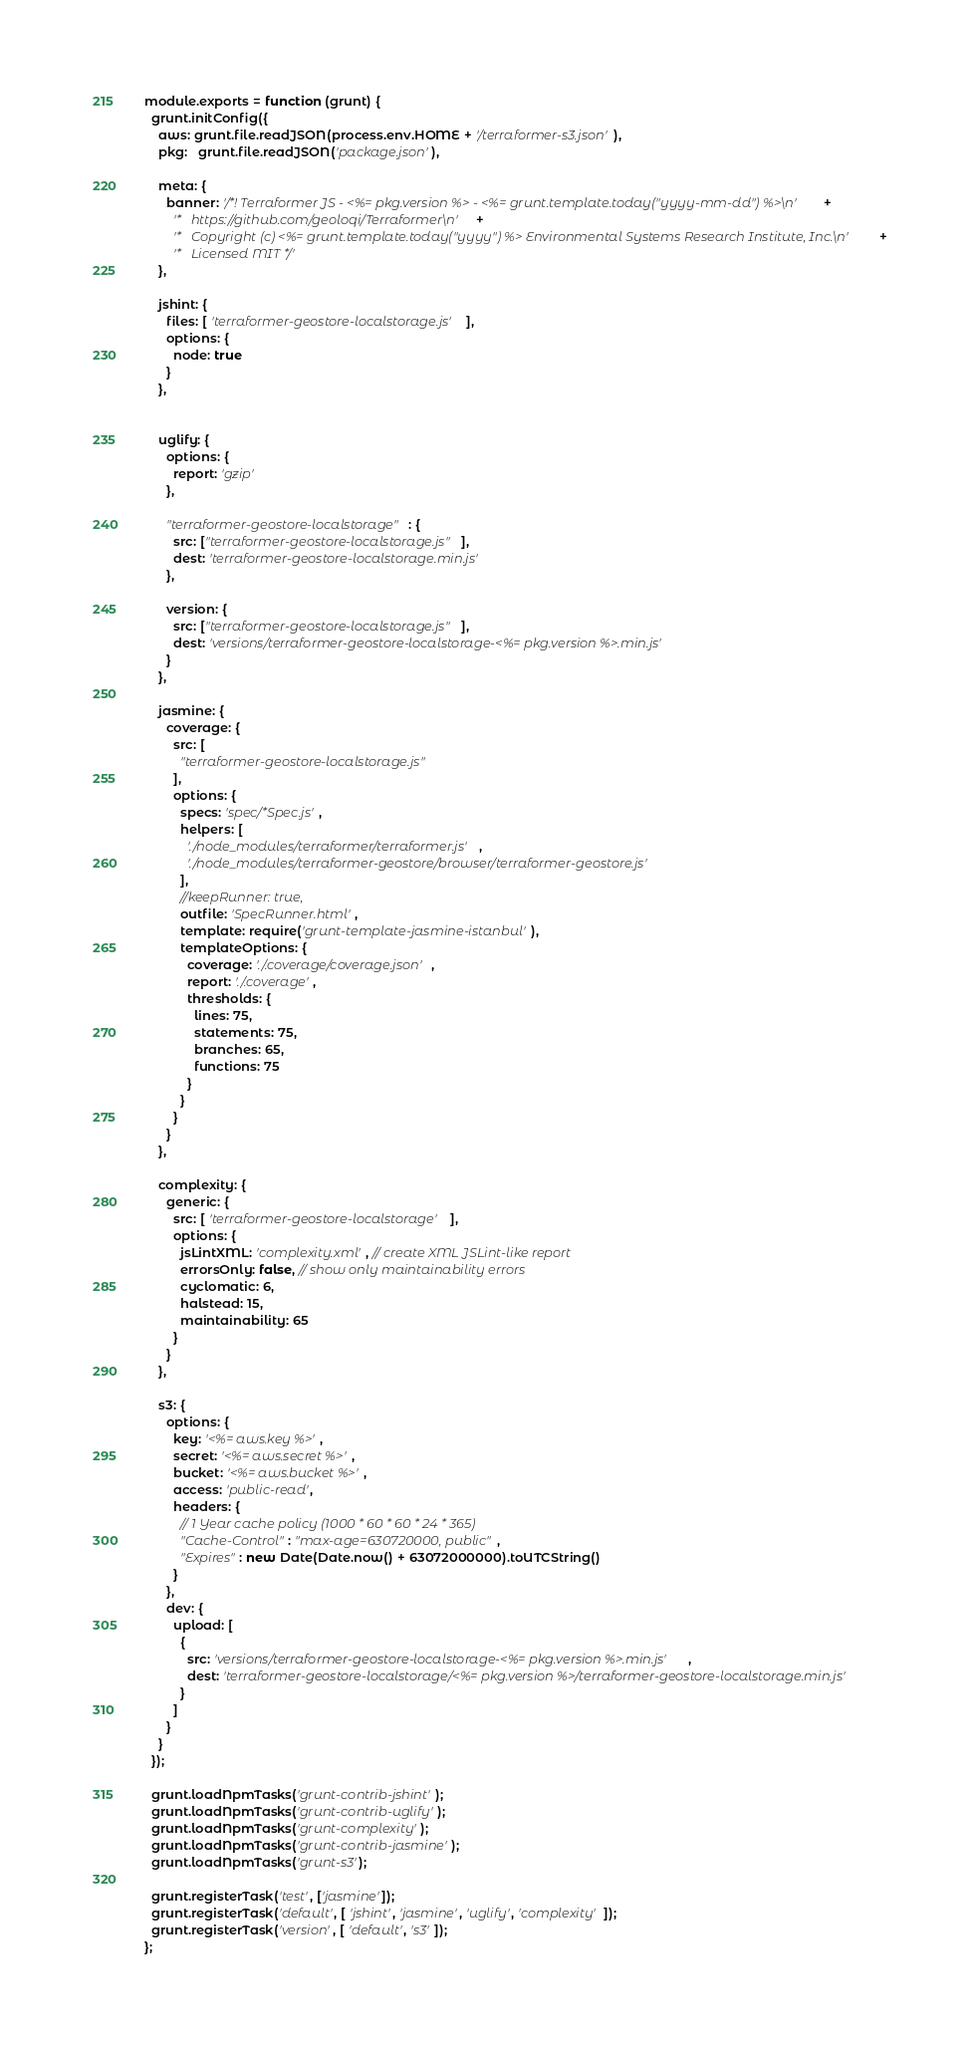Convert code to text. <code><loc_0><loc_0><loc_500><loc_500><_JavaScript_>module.exports = function (grunt) {
  grunt.initConfig({
    aws: grunt.file.readJSON(process.env.HOME + '/terraformer-s3.json'),
    pkg:   grunt.file.readJSON('package.json'),

    meta: {
      banner: '/*! Terraformer JS - <%= pkg.version %> - <%= grunt.template.today("yyyy-mm-dd") %>\n' +
        '*   https://github.com/geoloqi/Terraformer\n' +
        '*   Copyright (c) <%= grunt.template.today("yyyy") %> Environmental Systems Research Institute, Inc.\n' +
        '*   Licensed MIT */'
    },

    jshint: {
      files: [ 'terraformer-geostore-localstorage.js' ],
      options: {
        node: true
      }
    },


    uglify: {
      options: {
        report: 'gzip'
      },

      "terraformer-geostore-localstorage": {
        src: ["terraformer-geostore-localstorage.js"],
        dest: 'terraformer-geostore-localstorage.min.js'
      },

      version: {
        src: ["terraformer-geostore-localstorage.js"],
        dest: 'versions/terraformer-geostore-localstorage-<%= pkg.version %>.min.js'
      }
    },

    jasmine: {
      coverage: {
        src: [
          "terraformer-geostore-localstorage.js"
        ],
        options: {
          specs: 'spec/*Spec.js',
          helpers: [
            './node_modules/terraformer/terraformer.js',
            './node_modules/terraformer-geostore/browser/terraformer-geostore.js'
          ],
          //keepRunner: true,
          outfile: 'SpecRunner.html',
          template: require('grunt-template-jasmine-istanbul'),
          templateOptions: {
            coverage: './.coverage/coverage.json',
            report: './.coverage',
            thresholds: {
              lines: 75,
              statements: 75,
              branches: 65,
              functions: 75
            }
          }
        }
      }
    },

    complexity: {
      generic: {
        src: [ 'terraformer-geostore-localstorage' ],
        options: {
          jsLintXML: 'complexity.xml', // create XML JSLint-like report
          errorsOnly: false, // show only maintainability errors
          cyclomatic: 6,
          halstead: 15,
          maintainability: 65
        }
      }
    },

    s3: {
      options: {
        key: '<%= aws.key %>',
        secret: '<%= aws.secret %>',
        bucket: '<%= aws.bucket %>',
        access: 'public-read',
        headers: {
          // 1 Year cache policy (1000 * 60 * 60 * 24 * 365)
          "Cache-Control": "max-age=630720000, public",
          "Expires": new Date(Date.now() + 63072000000).toUTCString()
        }
      },
      dev: {
        upload: [
          {
            src: 'versions/terraformer-geostore-localstorage-<%= pkg.version %>.min.js',
            dest: 'terraformer-geostore-localstorage/<%= pkg.version %>/terraformer-geostore-localstorage.min.js'
          }
        ]
      }
    }
  });

  grunt.loadNpmTasks('grunt-contrib-jshint');
  grunt.loadNpmTasks('grunt-contrib-uglify');
  grunt.loadNpmTasks('grunt-complexity');
  grunt.loadNpmTasks('grunt-contrib-jasmine');
  grunt.loadNpmTasks('grunt-s3');

  grunt.registerTask('test', ['jasmine']);
  grunt.registerTask('default', [ 'jshint', 'jasmine', 'uglify', 'complexity' ]);
  grunt.registerTask('version', [ 'default', 's3' ]);
};
</code> 